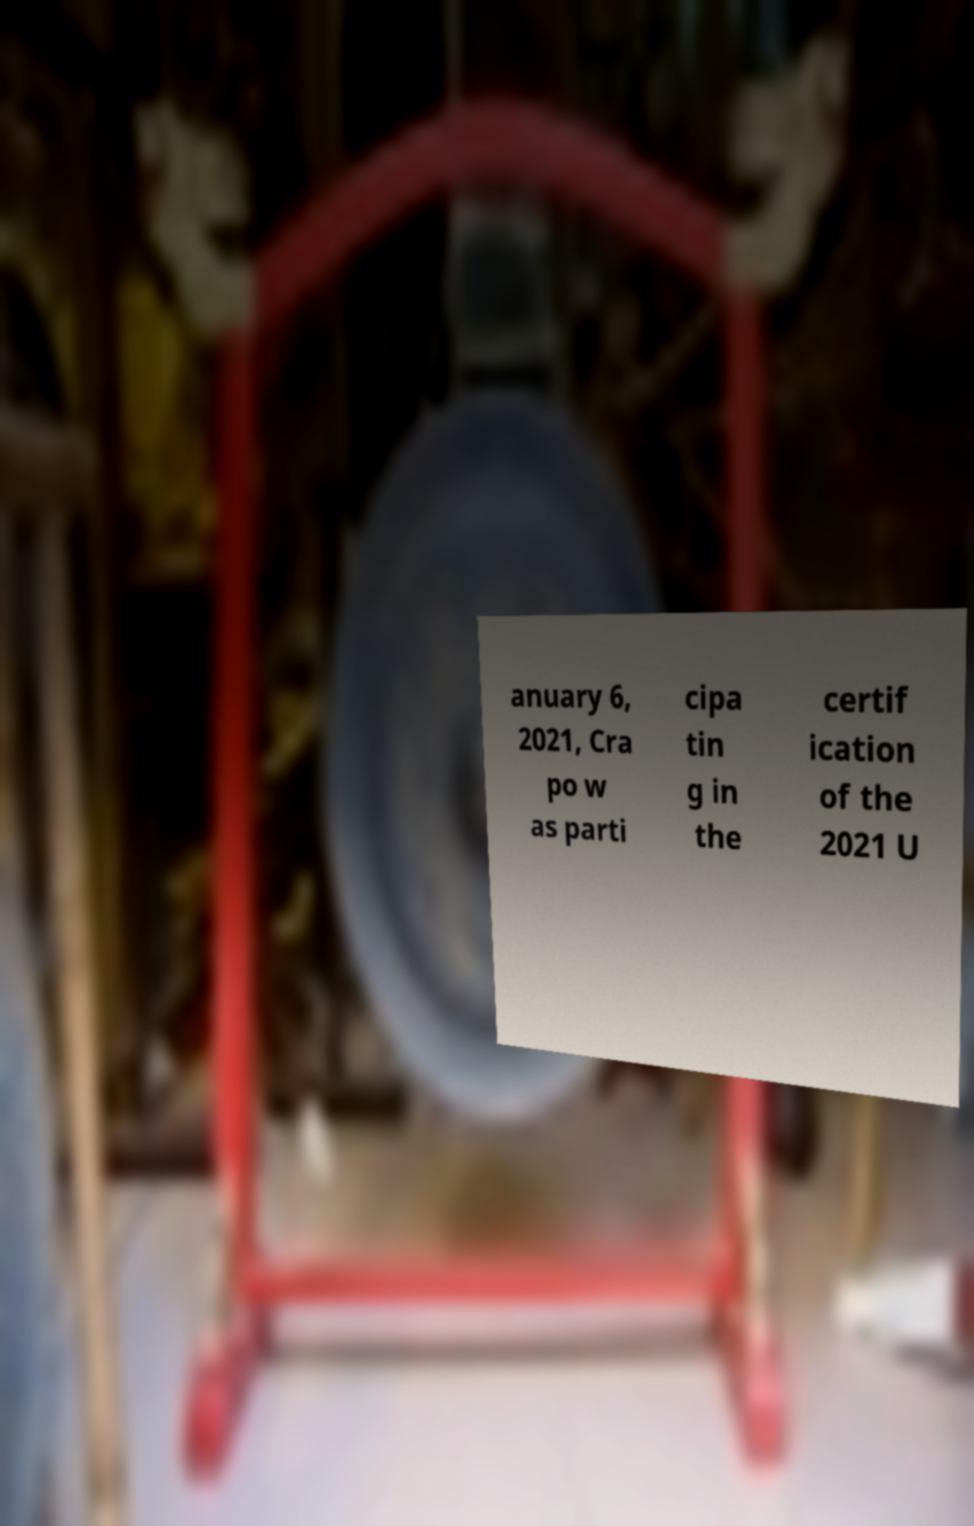What messages or text are displayed in this image? I need them in a readable, typed format. anuary 6, 2021, Cra po w as parti cipa tin g in the certif ication of the 2021 U 